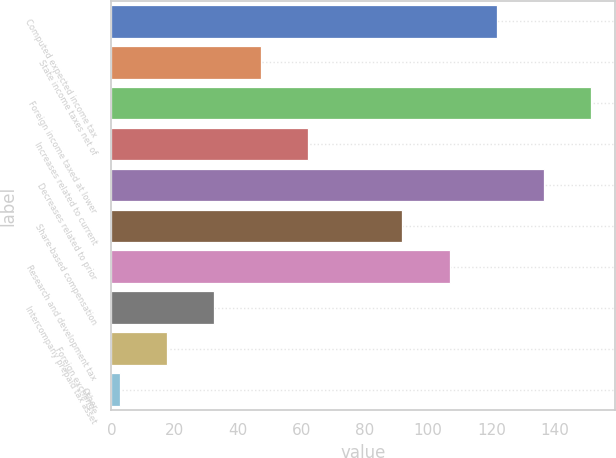Convert chart. <chart><loc_0><loc_0><loc_500><loc_500><bar_chart><fcel>Computed expected income tax<fcel>State income taxes net of<fcel>Foreign income taxed at lower<fcel>Increases related to current<fcel>Decreases related to prior<fcel>Share-based compensation<fcel>Research and development tax<fcel>Intercompany prepaid tax asset<fcel>Foreign exchange<fcel>Other<nl><fcel>121.64<fcel>47.24<fcel>151.4<fcel>62.12<fcel>136.52<fcel>91.88<fcel>106.76<fcel>32.36<fcel>17.48<fcel>2.6<nl></chart> 